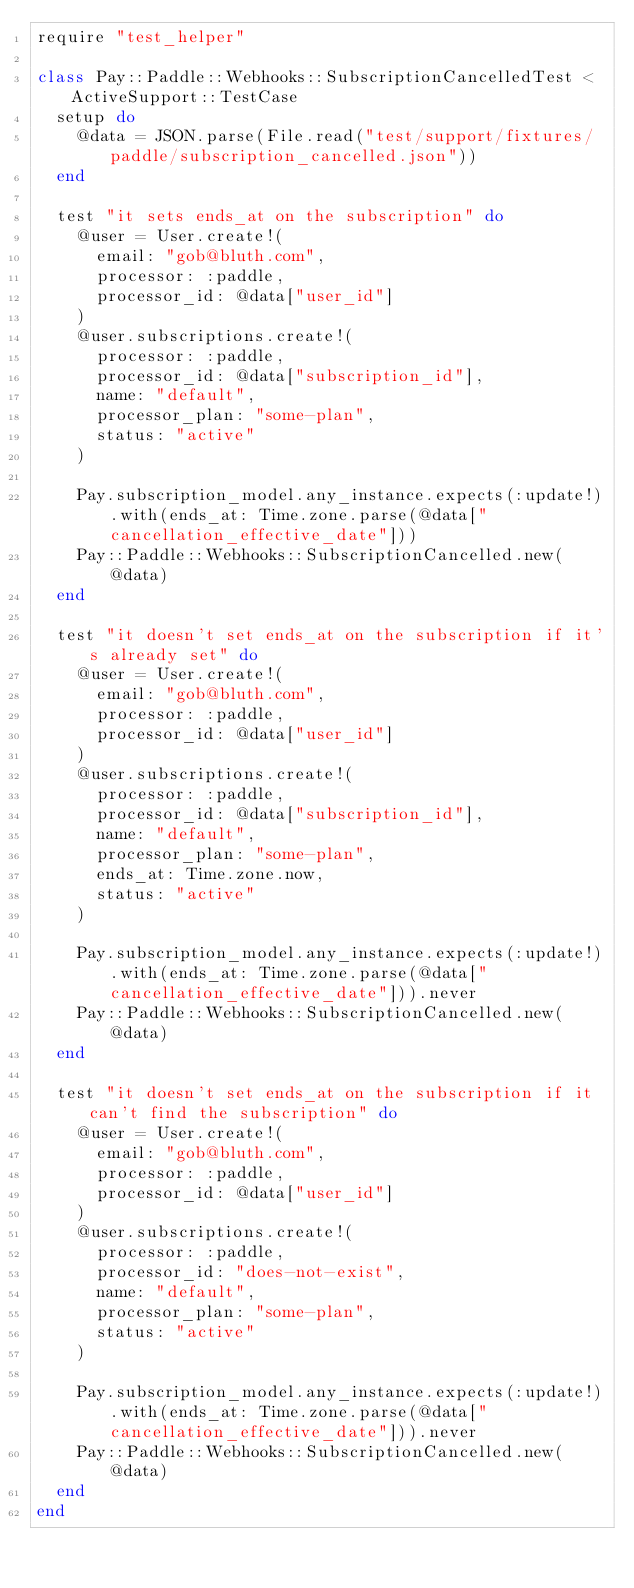<code> <loc_0><loc_0><loc_500><loc_500><_Ruby_>require "test_helper"

class Pay::Paddle::Webhooks::SubscriptionCancelledTest < ActiveSupport::TestCase
  setup do
    @data = JSON.parse(File.read("test/support/fixtures/paddle/subscription_cancelled.json"))
  end

  test "it sets ends_at on the subscription" do
    @user = User.create!(
      email: "gob@bluth.com",
      processor: :paddle,
      processor_id: @data["user_id"]
    )
    @user.subscriptions.create!(
      processor: :paddle,
      processor_id: @data["subscription_id"],
      name: "default",
      processor_plan: "some-plan",
      status: "active"
    )

    Pay.subscription_model.any_instance.expects(:update!).with(ends_at: Time.zone.parse(@data["cancellation_effective_date"]))
    Pay::Paddle::Webhooks::SubscriptionCancelled.new(@data)
  end

  test "it doesn't set ends_at on the subscription if it's already set" do
    @user = User.create!(
      email: "gob@bluth.com",
      processor: :paddle,
      processor_id: @data["user_id"]
    )
    @user.subscriptions.create!(
      processor: :paddle,
      processor_id: @data["subscription_id"],
      name: "default",
      processor_plan: "some-plan",
      ends_at: Time.zone.now,
      status: "active"
    )

    Pay.subscription_model.any_instance.expects(:update!).with(ends_at: Time.zone.parse(@data["cancellation_effective_date"])).never
    Pay::Paddle::Webhooks::SubscriptionCancelled.new(@data)
  end

  test "it doesn't set ends_at on the subscription if it can't find the subscription" do
    @user = User.create!(
      email: "gob@bluth.com",
      processor: :paddle,
      processor_id: @data["user_id"]
    )
    @user.subscriptions.create!(
      processor: :paddle,
      processor_id: "does-not-exist",
      name: "default",
      processor_plan: "some-plan",
      status: "active"
    )

    Pay.subscription_model.any_instance.expects(:update!).with(ends_at: Time.zone.parse(@data["cancellation_effective_date"])).never
    Pay::Paddle::Webhooks::SubscriptionCancelled.new(@data)
  end
end
</code> 